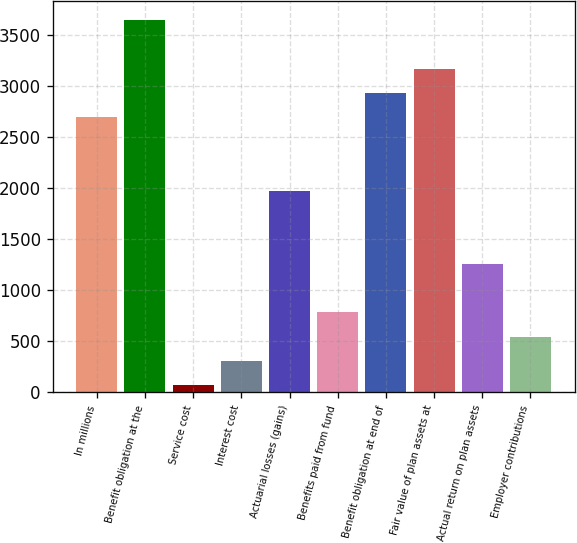Convert chart. <chart><loc_0><loc_0><loc_500><loc_500><bar_chart><fcel>In millions<fcel>Benefit obligation at the<fcel>Service cost<fcel>Interest cost<fcel>Actuarial losses (gains)<fcel>Benefits paid from fund<fcel>Benefit obligation at end of<fcel>Fair value of plan assets at<fcel>Actual return on plan assets<fcel>Employer contributions<nl><fcel>2692.4<fcel>3646<fcel>70<fcel>308.4<fcel>1977.2<fcel>785.2<fcel>2930.8<fcel>3169.2<fcel>1262<fcel>546.8<nl></chart> 